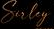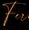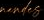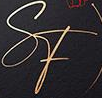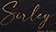Read the text content from these images in order, separated by a semicolon. Suley; Fu; #####; SF; Suley 